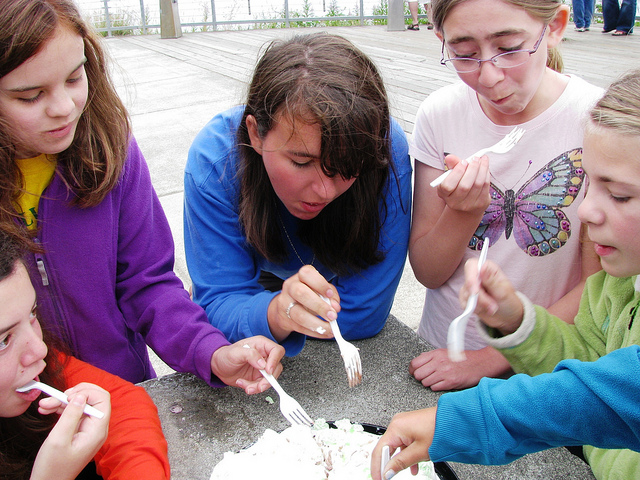<image>What is the mood of the girl in blue? It is ambiguous to tell the mood of the girl in blue. What is the mood of the girl in blue? I don't know what is the mood of the girl in blue. It could be tired, happy, hungry, uncertain, surprised, sad, confused, or any other emotion. 